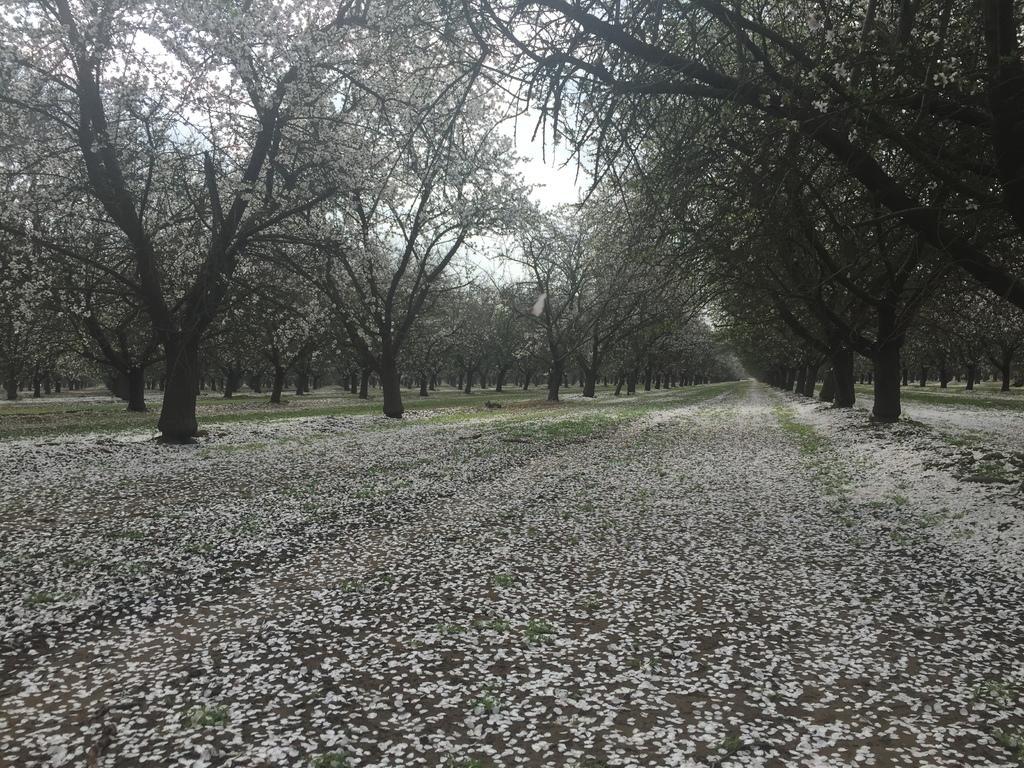Describe this image in one or two sentences. As we can see in the image there are trees and sky. 